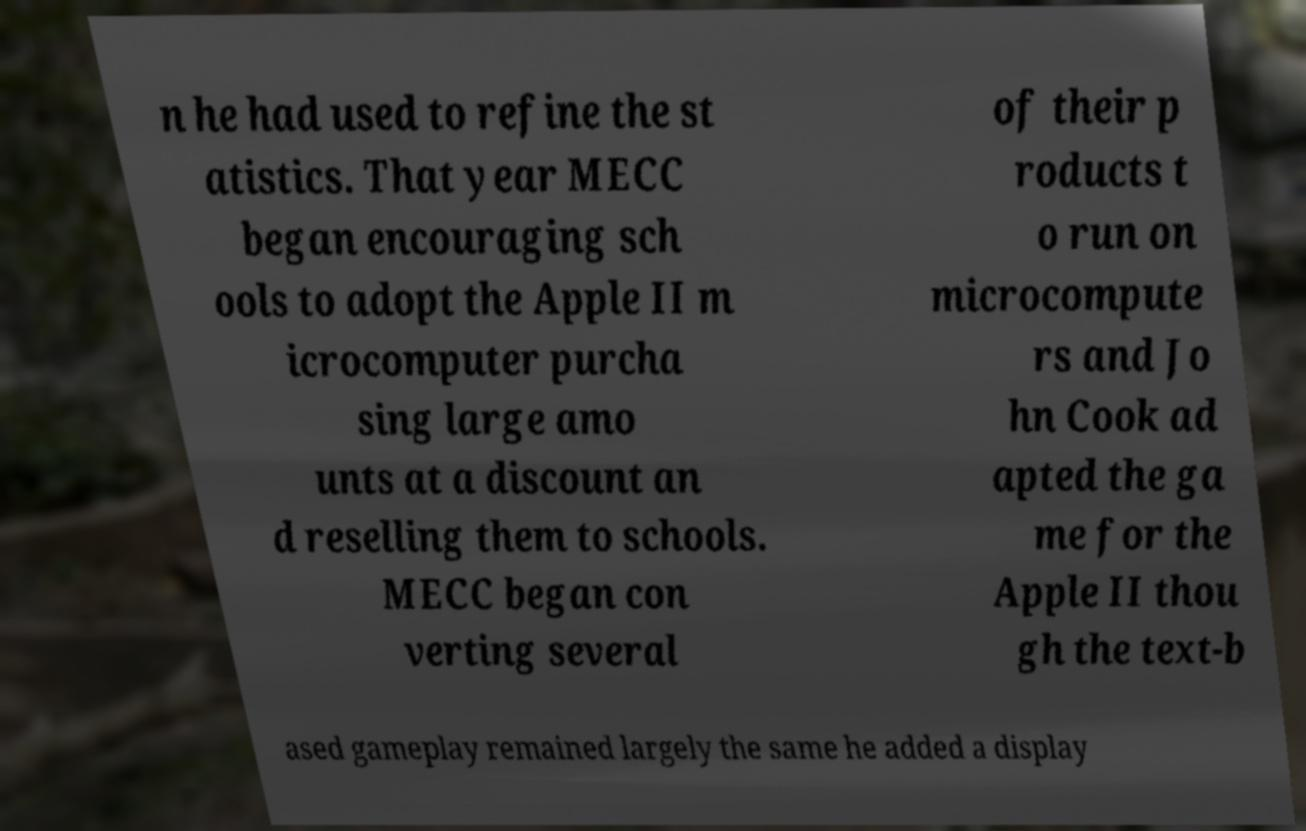I need the written content from this picture converted into text. Can you do that? n he had used to refine the st atistics. That year MECC began encouraging sch ools to adopt the Apple II m icrocomputer purcha sing large amo unts at a discount an d reselling them to schools. MECC began con verting several of their p roducts t o run on microcompute rs and Jo hn Cook ad apted the ga me for the Apple II thou gh the text-b ased gameplay remained largely the same he added a display 